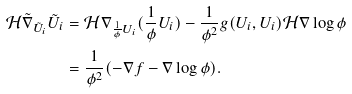<formula> <loc_0><loc_0><loc_500><loc_500>\mathcal { H } { \tilde { \nabla } } _ { { \tilde { U } } _ { i } } { \tilde { U } } _ { i } & = \mathcal { H } \nabla _ { \frac { 1 } { \phi } U _ { i } } ( \frac { 1 } { \phi } U _ { i } ) - \frac { 1 } { \phi ^ { 2 } } g ( U _ { i } , U _ { i } ) \mathcal { H } \nabla \log \phi \\ & = \frac { 1 } { \phi ^ { 2 } } ( - \nabla f - \nabla \log \phi ) .</formula> 